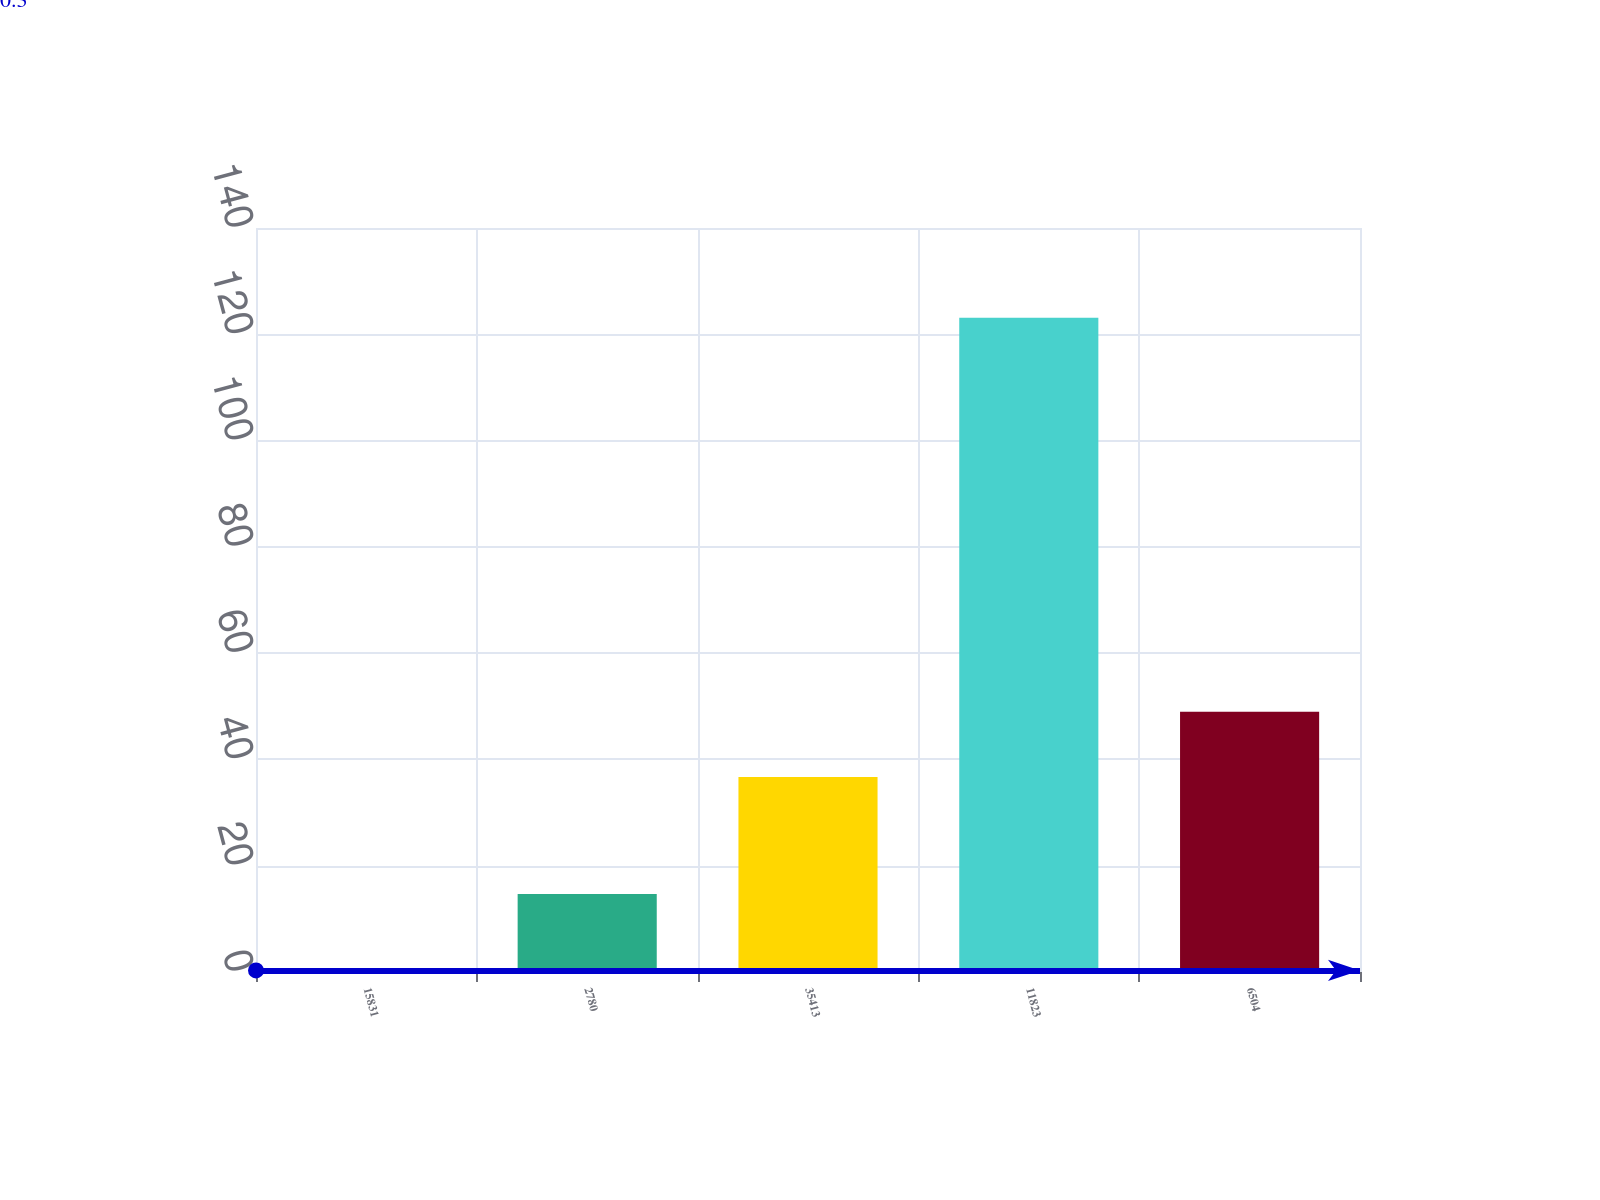<chart> <loc_0><loc_0><loc_500><loc_500><bar_chart><fcel>15831<fcel>2780<fcel>35413<fcel>11823<fcel>6504<nl><fcel>0.3<fcel>14.7<fcel>36.7<fcel>123.1<fcel>48.98<nl></chart> 